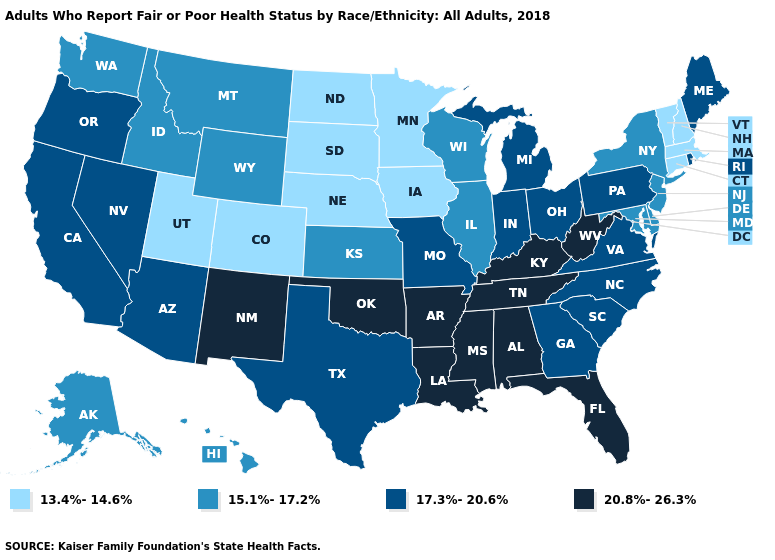How many symbols are there in the legend?
Short answer required. 4. Does the map have missing data?
Quick response, please. No. Name the states that have a value in the range 13.4%-14.6%?
Keep it brief. Colorado, Connecticut, Iowa, Massachusetts, Minnesota, Nebraska, New Hampshire, North Dakota, South Dakota, Utah, Vermont. What is the lowest value in the USA?
Quick response, please. 13.4%-14.6%. What is the value of California?
Be succinct. 17.3%-20.6%. What is the value of Ohio?
Give a very brief answer. 17.3%-20.6%. Name the states that have a value in the range 15.1%-17.2%?
Keep it brief. Alaska, Delaware, Hawaii, Idaho, Illinois, Kansas, Maryland, Montana, New Jersey, New York, Washington, Wisconsin, Wyoming. What is the lowest value in the USA?
Be succinct. 13.4%-14.6%. Name the states that have a value in the range 15.1%-17.2%?
Answer briefly. Alaska, Delaware, Hawaii, Idaho, Illinois, Kansas, Maryland, Montana, New Jersey, New York, Washington, Wisconsin, Wyoming. What is the value of New York?
Concise answer only. 15.1%-17.2%. Name the states that have a value in the range 13.4%-14.6%?
Keep it brief. Colorado, Connecticut, Iowa, Massachusetts, Minnesota, Nebraska, New Hampshire, North Dakota, South Dakota, Utah, Vermont. What is the lowest value in states that border Nebraska?
Give a very brief answer. 13.4%-14.6%. What is the lowest value in the West?
Be succinct. 13.4%-14.6%. Does Maryland have the lowest value in the South?
Write a very short answer. Yes. What is the highest value in states that border Oklahoma?
Keep it brief. 20.8%-26.3%. 